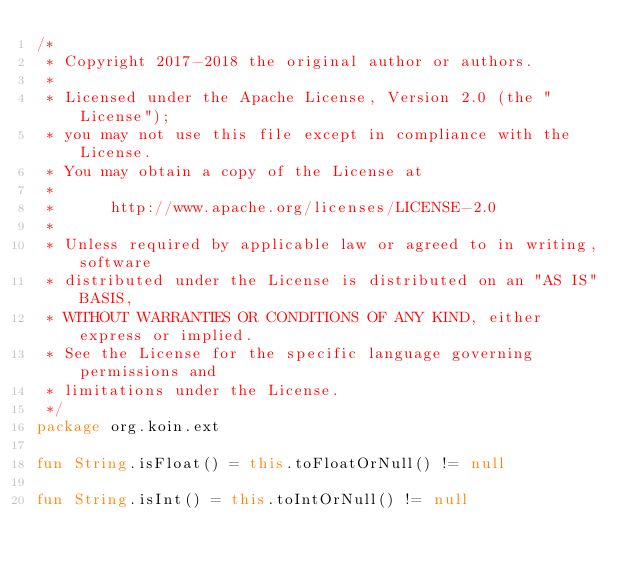Convert code to text. <code><loc_0><loc_0><loc_500><loc_500><_Kotlin_>/*
 * Copyright 2017-2018 the original author or authors.
 *
 * Licensed under the Apache License, Version 2.0 (the "License");
 * you may not use this file except in compliance with the License.
 * You may obtain a copy of the License at
 *
 *      http://www.apache.org/licenses/LICENSE-2.0
 *
 * Unless required by applicable law or agreed to in writing, software
 * distributed under the License is distributed on an "AS IS" BASIS,
 * WITHOUT WARRANTIES OR CONDITIONS OF ANY KIND, either express or implied.
 * See the License for the specific language governing permissions and
 * limitations under the License.
 */
package org.koin.ext

fun String.isFloat() = this.toFloatOrNull() != null

fun String.isInt() = this.toIntOrNull() != null</code> 